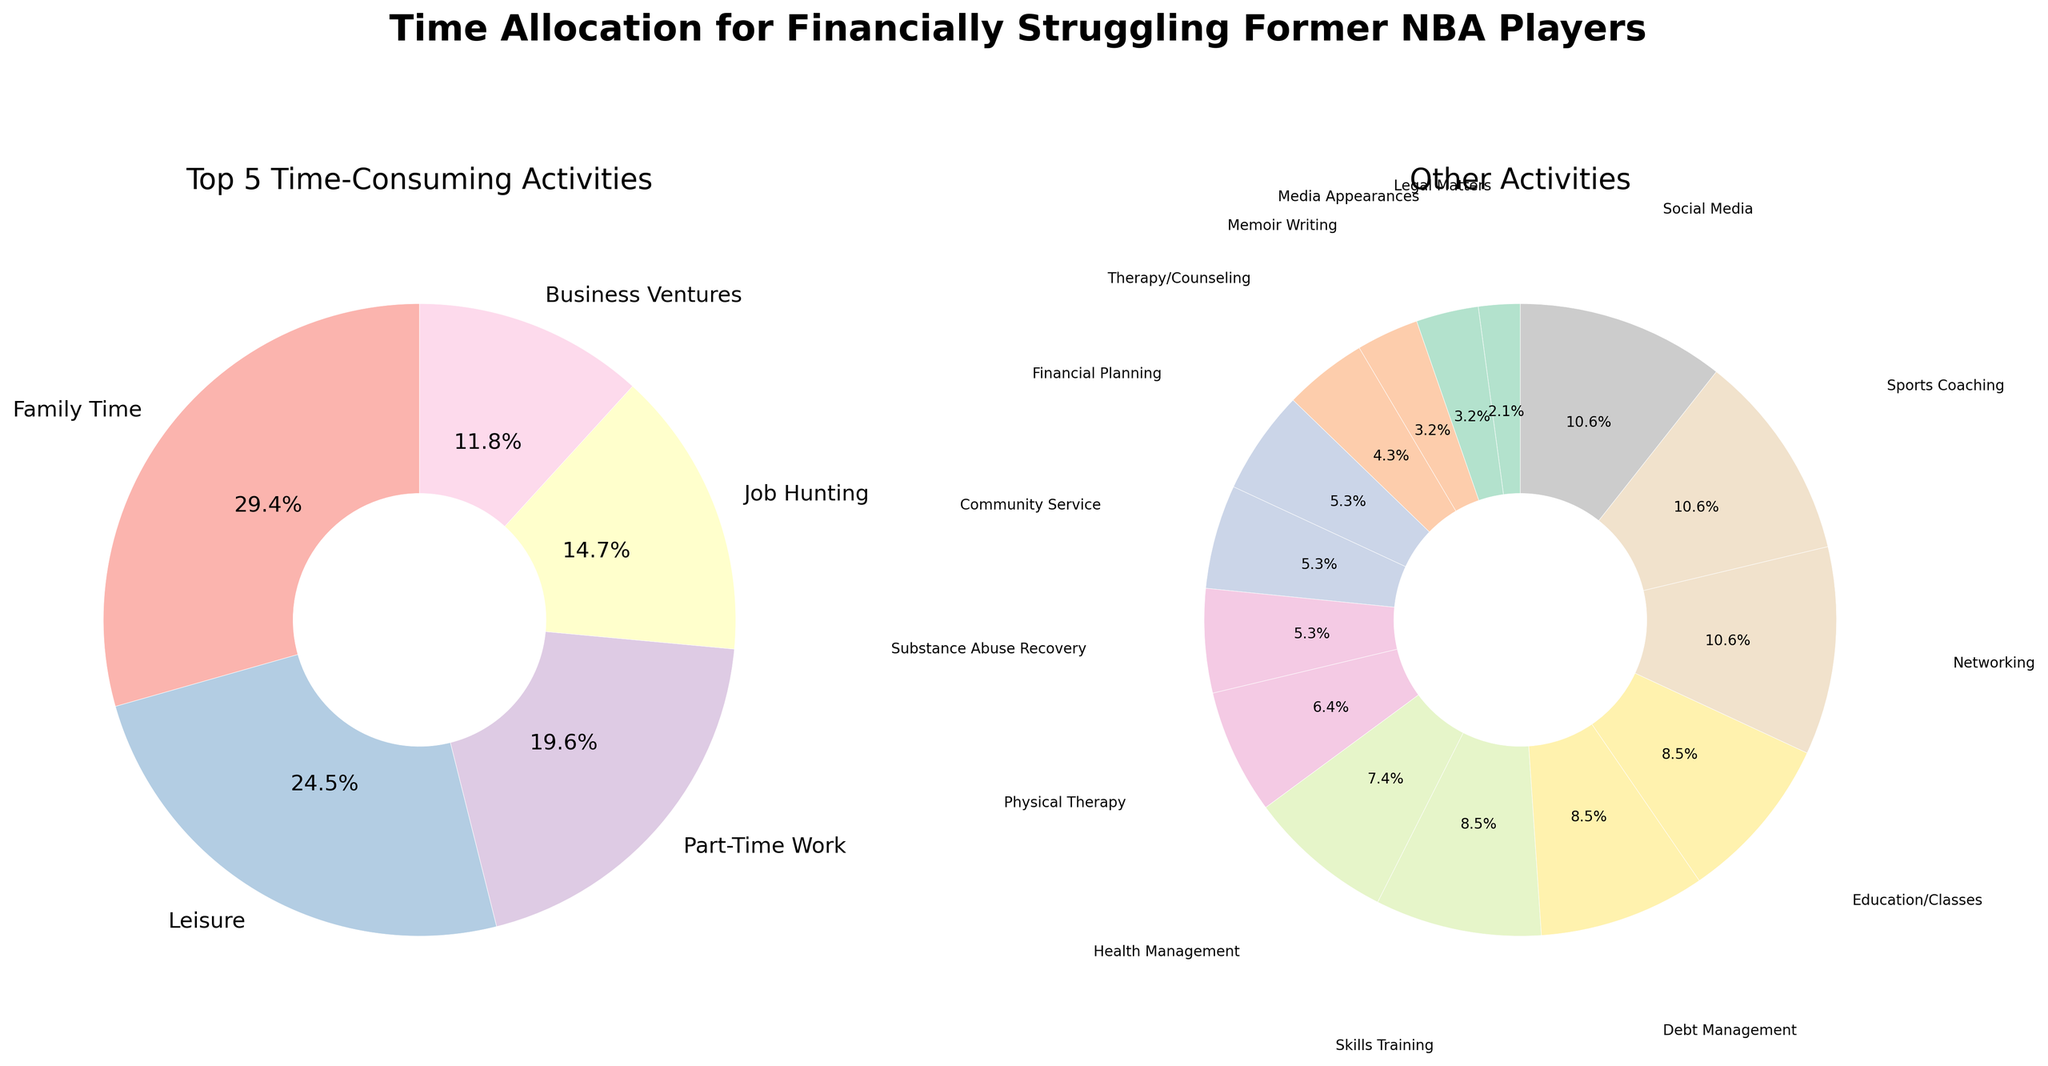What percentage of the time is spent on the top activity? Refer to the left pie chart labeled "Top 5 Time-Consuming Activities" and find the percentage for the largest segment. The largest segment is "Family Time" which has the percentage labeled as 25.5%.
Answer: 25.5% How much more time is spent on Family Time than on Leisure? From the left pie chart, Family Time takes up 30 hours and Leisure takes up 25 hours. Subtract Leisure hours from Family Time hours. 30 - 25 = 5.
Answer: 5 hours Which activities take up the smallest percentages of time in the "Other Activities" pie chart? Look at the right pie chart labeled "Other Activities" for the smallest slices. "Legal Matters" and "Memoir Writing" are the smallest areas. Both are labeled as 1.1%.
Answer: Legal Matters and Memoir Writing Compare the amount of time spent on Job Hunting and Part-Time Work. Which one is higher? From the left pie chart, Job Hunting is 15 hours and Part-Time Work is 20 hours. Part-Time Work is higher.
Answer: Part-Time Work What is the combined time spent on Financial Planning, Debt Management, and Substance Abuse Recovery? Refer to the right pie chart, Financial Planning is 5 hours, Debt Management is 8 hours, and Substance Abuse Recovery is 5 hours. Sum them up: 5 + 8 + 5 = 18.
Answer: 18 hours How much time is spent on Networking compared to Sports Coaching and Media Appearances combined? Networking is 10 hours. Sports Coaching is 10 hours and Media Appearances is 3 hours, summing them up: 10 + 3 = 13. Networking (10 hours) is 3 hours less than the combined time of Sports Coaching and Media Appearances (13 hours).
Answer: 3 hours less Which activity in the "Other Activities" pie chart has the largest wedge area? Refer to the right pie chart and find the largest segment. "Business Ventures" has the largest percentage labeled as 9.7%.
Answer: Business Ventures How many more hours per week are spent on Part-Time Work compared to Financial Planning and Legal Matters combined? Part-Time Work from the left pie chart is 20 hours. Financial Planning is 5 hours and Legal Matters is 2 hours, summing them up: 5 + 2 = 7. Subtract the combined time from Part-Time Work: 20 - 7 = 13.
Answer: 13 hours What visual attributes distinguish the top 5 activities pie chart from the other activities pie chart? The left pie chart uses a palette from Pastel1 with larger text labels due to fewer segments, while the right pie chart uses a palette from Pastel2 with smaller segments and text labels due to more categories.
Answer: Different color palettes and text sizes What is the second most time-consuming activity from the "Top 5 Time-Consuming Activities" pie chart? Refer to the left pie chart, the second-largest segment after "Family Time" (30 hours) is "Leisure" with 25 hours.
Answer: Leisure 